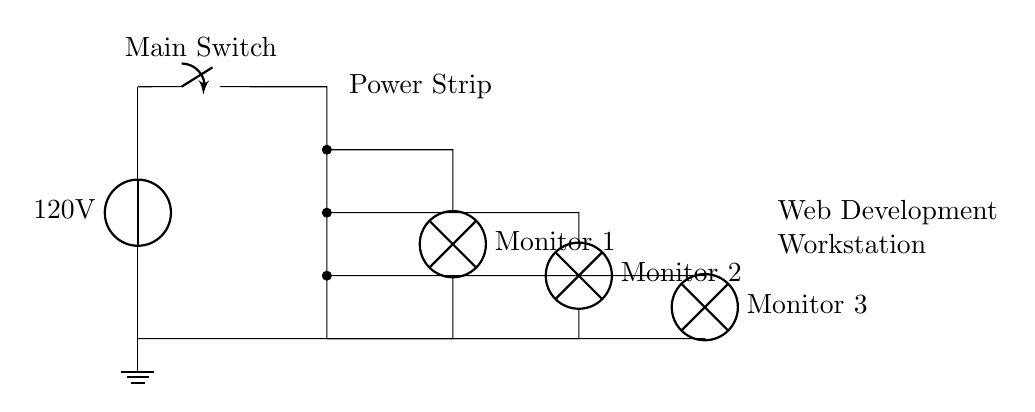What is the voltage of this circuit? The voltage is 120 volts, which is indicated by the voltage source symbol in the circuit.
Answer: 120 volts What type of component connects the power source and the monitors? The component is a power strip, which is depicted in the diagram as a line connecting the voltage source to the monitors, allowing multiple connections.
Answer: Power strip How many monitors are connected to the circuit? There are three monitors connected, as represented by three lamp symbols labeled "Monitor 1," "Monitor 2," and "Monitor 3" in the circuit.
Answer: Three What is the purpose of the main switch? The main switch controls the flow of electricity from the power source to the entire circuit, allowing users to turn the power on or off as needed.
Answer: To control the circuit Which component indicates a ground connection? The component indicating a ground connection is the ground symbol at the bottom of the diagram, which shows the reference point for the circuit.
Answer: Ground If all monitors are operating, what might be a potential risk in this circuit configuration? A potential risk is overloading, as connecting multiple high-power appliances can exceed the current capacity of the wiring, leading to overheating or tripping circuit protection.
Answer: Overloading 